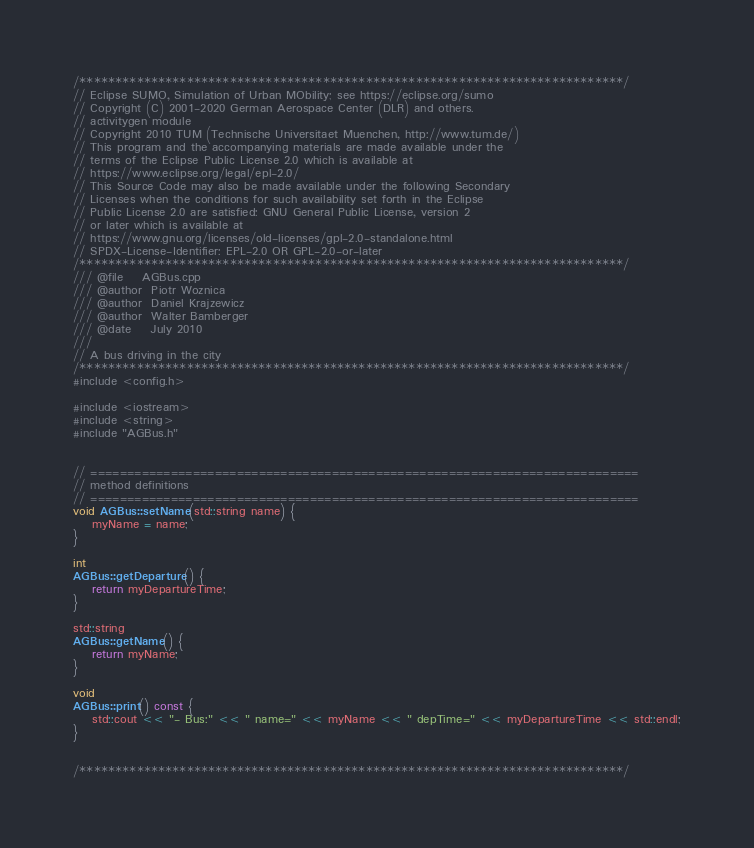<code> <loc_0><loc_0><loc_500><loc_500><_C++_>/****************************************************************************/
// Eclipse SUMO, Simulation of Urban MObility; see https://eclipse.org/sumo
// Copyright (C) 2001-2020 German Aerospace Center (DLR) and others.
// activitygen module
// Copyright 2010 TUM (Technische Universitaet Muenchen, http://www.tum.de/)
// This program and the accompanying materials are made available under the
// terms of the Eclipse Public License 2.0 which is available at
// https://www.eclipse.org/legal/epl-2.0/
// This Source Code may also be made available under the following Secondary
// Licenses when the conditions for such availability set forth in the Eclipse
// Public License 2.0 are satisfied: GNU General Public License, version 2
// or later which is available at
// https://www.gnu.org/licenses/old-licenses/gpl-2.0-standalone.html
// SPDX-License-Identifier: EPL-2.0 OR GPL-2.0-or-later
/****************************************************************************/
/// @file    AGBus.cpp
/// @author  Piotr Woznica
/// @author  Daniel Krajzewicz
/// @author  Walter Bamberger
/// @date    July 2010
///
// A bus driving in the city
/****************************************************************************/
#include <config.h>

#include <iostream>
#include <string>
#include "AGBus.h"


// ===========================================================================
// method definitions
// ===========================================================================
void AGBus::setName(std::string name) {
    myName = name;
}

int
AGBus::getDeparture() {
    return myDepartureTime;
}

std::string
AGBus::getName() {
    return myName;
}

void
AGBus::print() const {
    std::cout << "- Bus:" << " name=" << myName << " depTime=" << myDepartureTime << std::endl;
}


/****************************************************************************/
</code> 